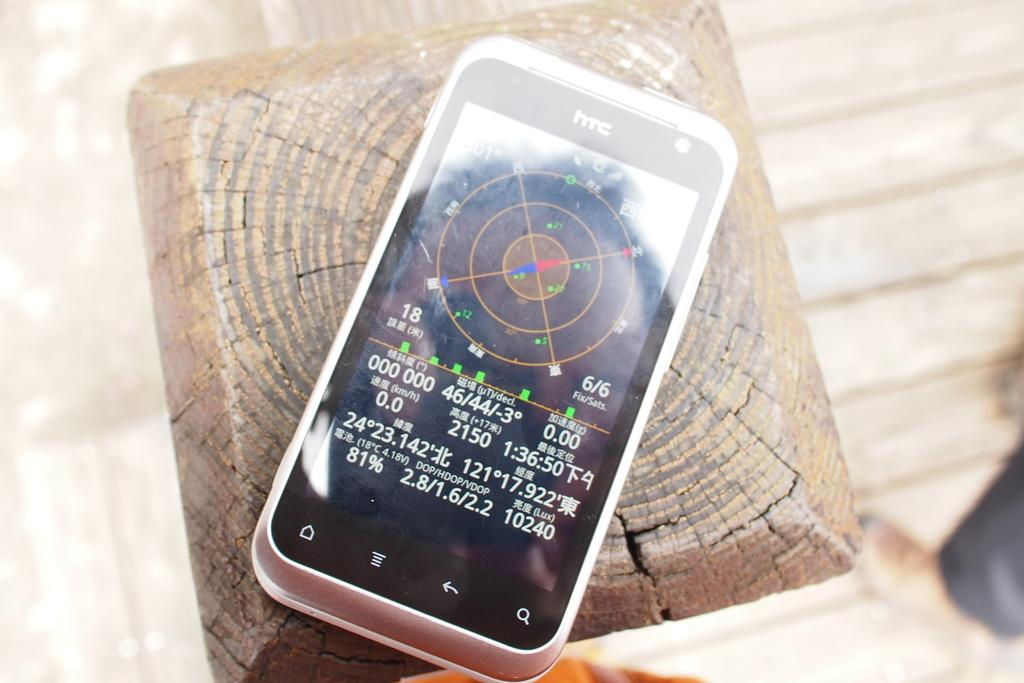<image>
Give a short and clear explanation of the subsequent image. a black and white htc phone with numbers like 46/44 on the screen 